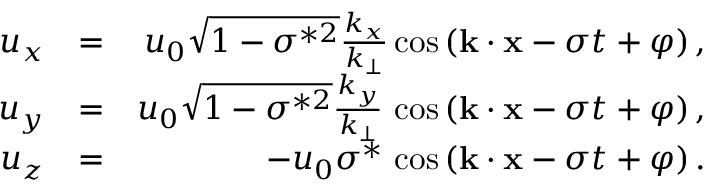<formula> <loc_0><loc_0><loc_500><loc_500>\begin{array} { r l r } { u _ { x } } & { = } & { u _ { 0 } \sqrt { 1 - \sigma ^ { * 2 } } \frac { k _ { x } } { k _ { \perp } } \cos { ( { k } \cdot { x } - \sigma t + \varphi ) } \, , } \\ { u _ { y } } & { = } & { u _ { 0 } \sqrt { 1 - \sigma ^ { * 2 } } \frac { k _ { y } } { k _ { \perp } } \, \cos { ( { k } \cdot { x } - \sigma t + \varphi ) } \, , } \\ { u _ { z } } & { = } & { - u _ { 0 } \sigma ^ { * } \, \cos { ( { k } \cdot { x } - \sigma t + \varphi ) } \, . } \end{array}</formula> 